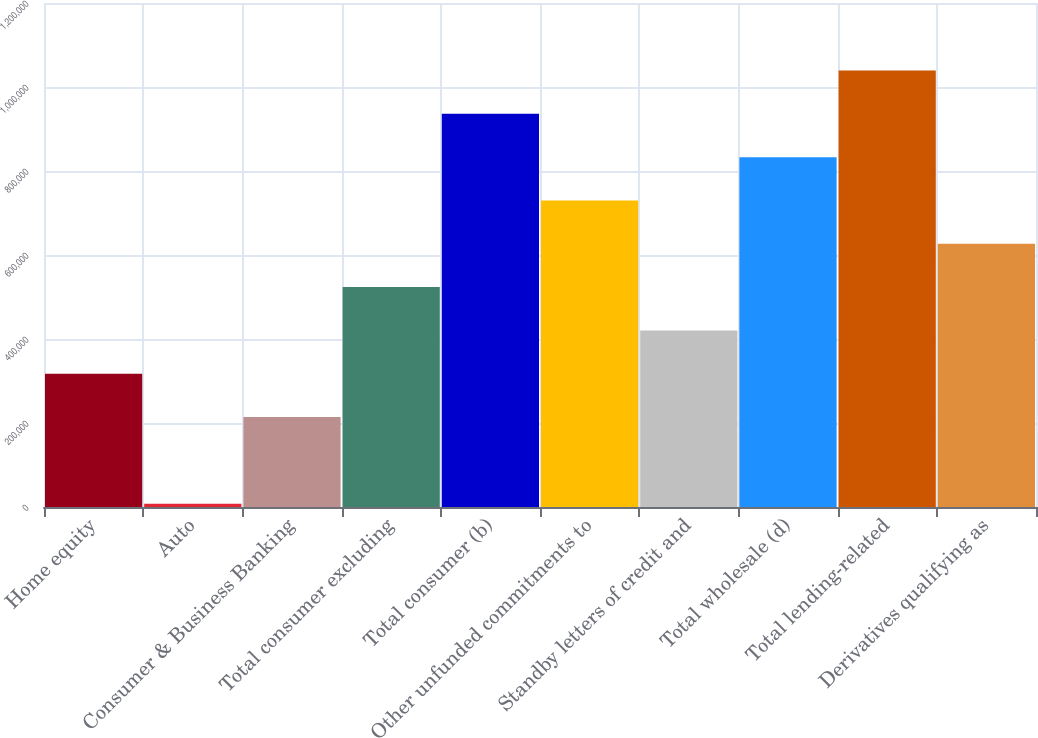Convert chart. <chart><loc_0><loc_0><loc_500><loc_500><bar_chart><fcel>Home equity<fcel>Auto<fcel>Consumer & Business Banking<fcel>Total consumer excluding<fcel>Total consumer (b)<fcel>Other unfunded commitments to<fcel>Standby letters of credit and<fcel>Total wholesale (d)<fcel>Total lending-related<fcel>Derivatives qualifying as<nl><fcel>317385<fcel>8011<fcel>214260<fcel>523634<fcel>936133<fcel>729884<fcel>420510<fcel>833009<fcel>1.03926e+06<fcel>626759<nl></chart> 